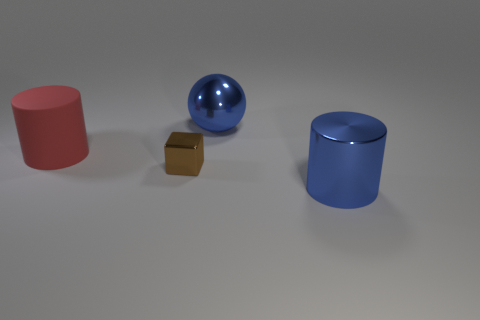Add 1 large metallic spheres. How many objects exist? 5 Subtract all spheres. How many objects are left? 3 Add 3 large objects. How many large objects exist? 6 Subtract 0 purple blocks. How many objects are left? 4 Subtract all brown cubes. Subtract all shiny blocks. How many objects are left? 2 Add 2 big metal balls. How many big metal balls are left? 3 